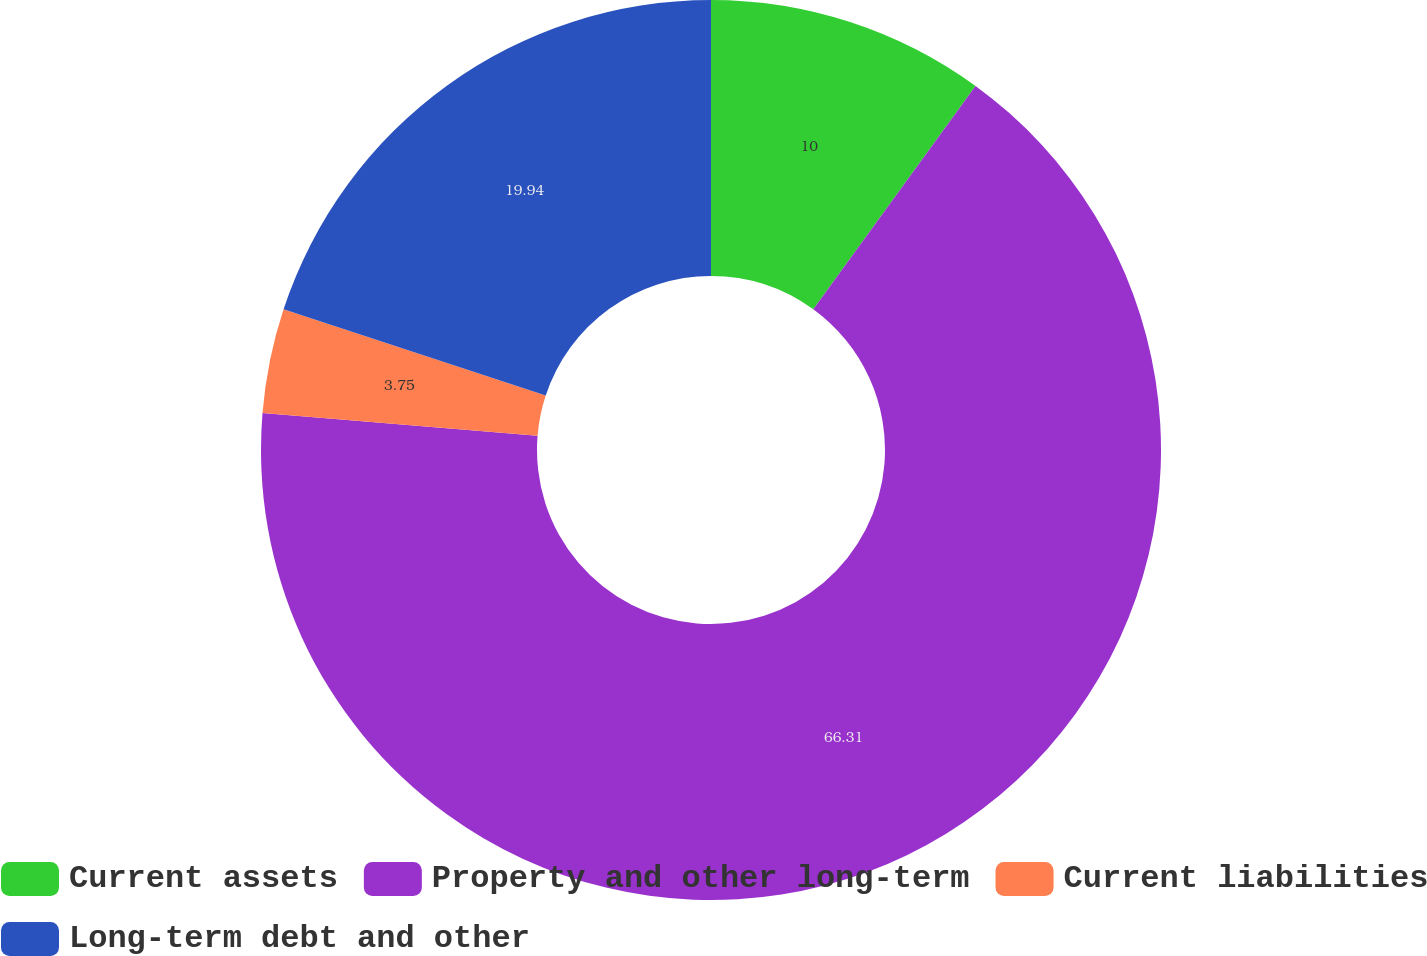Convert chart to OTSL. <chart><loc_0><loc_0><loc_500><loc_500><pie_chart><fcel>Current assets<fcel>Property and other long-term<fcel>Current liabilities<fcel>Long-term debt and other<nl><fcel>10.0%<fcel>66.31%<fcel>3.75%<fcel>19.94%<nl></chart> 